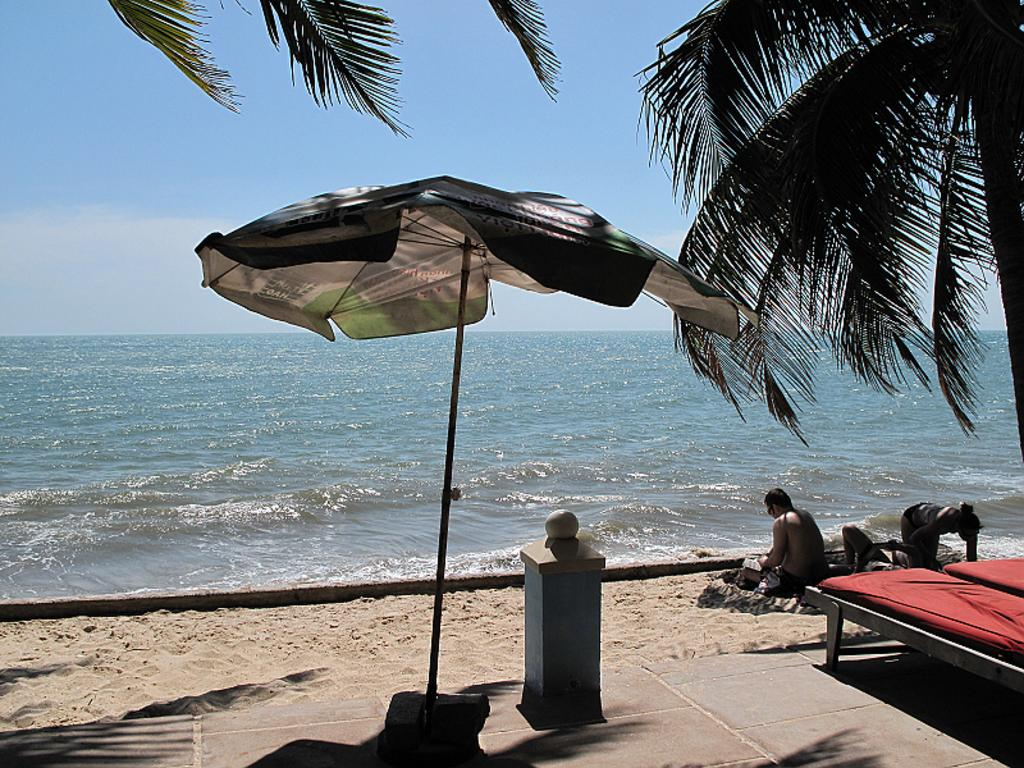What are the people in the image doing? The people in the image are lying on the sand. What type of vegetation can be seen in the image? There are trees in the image. What is the ground made of in the image? There is sand visible in the image. What is visible in the background of the image? There is an ocean in the background of the image. What is the condition of the sky in the image? The sky is clear in the image. What type of trade is taking place between the people in the image? There is no indication of any trade taking place in the image; the people are simply lying on the sand. What is the ice like in the image? There is no ice present in the image; it features people lying on sand near an ocean. 